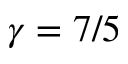Convert formula to latex. <formula><loc_0><loc_0><loc_500><loc_500>\gamma = 7 / 5</formula> 